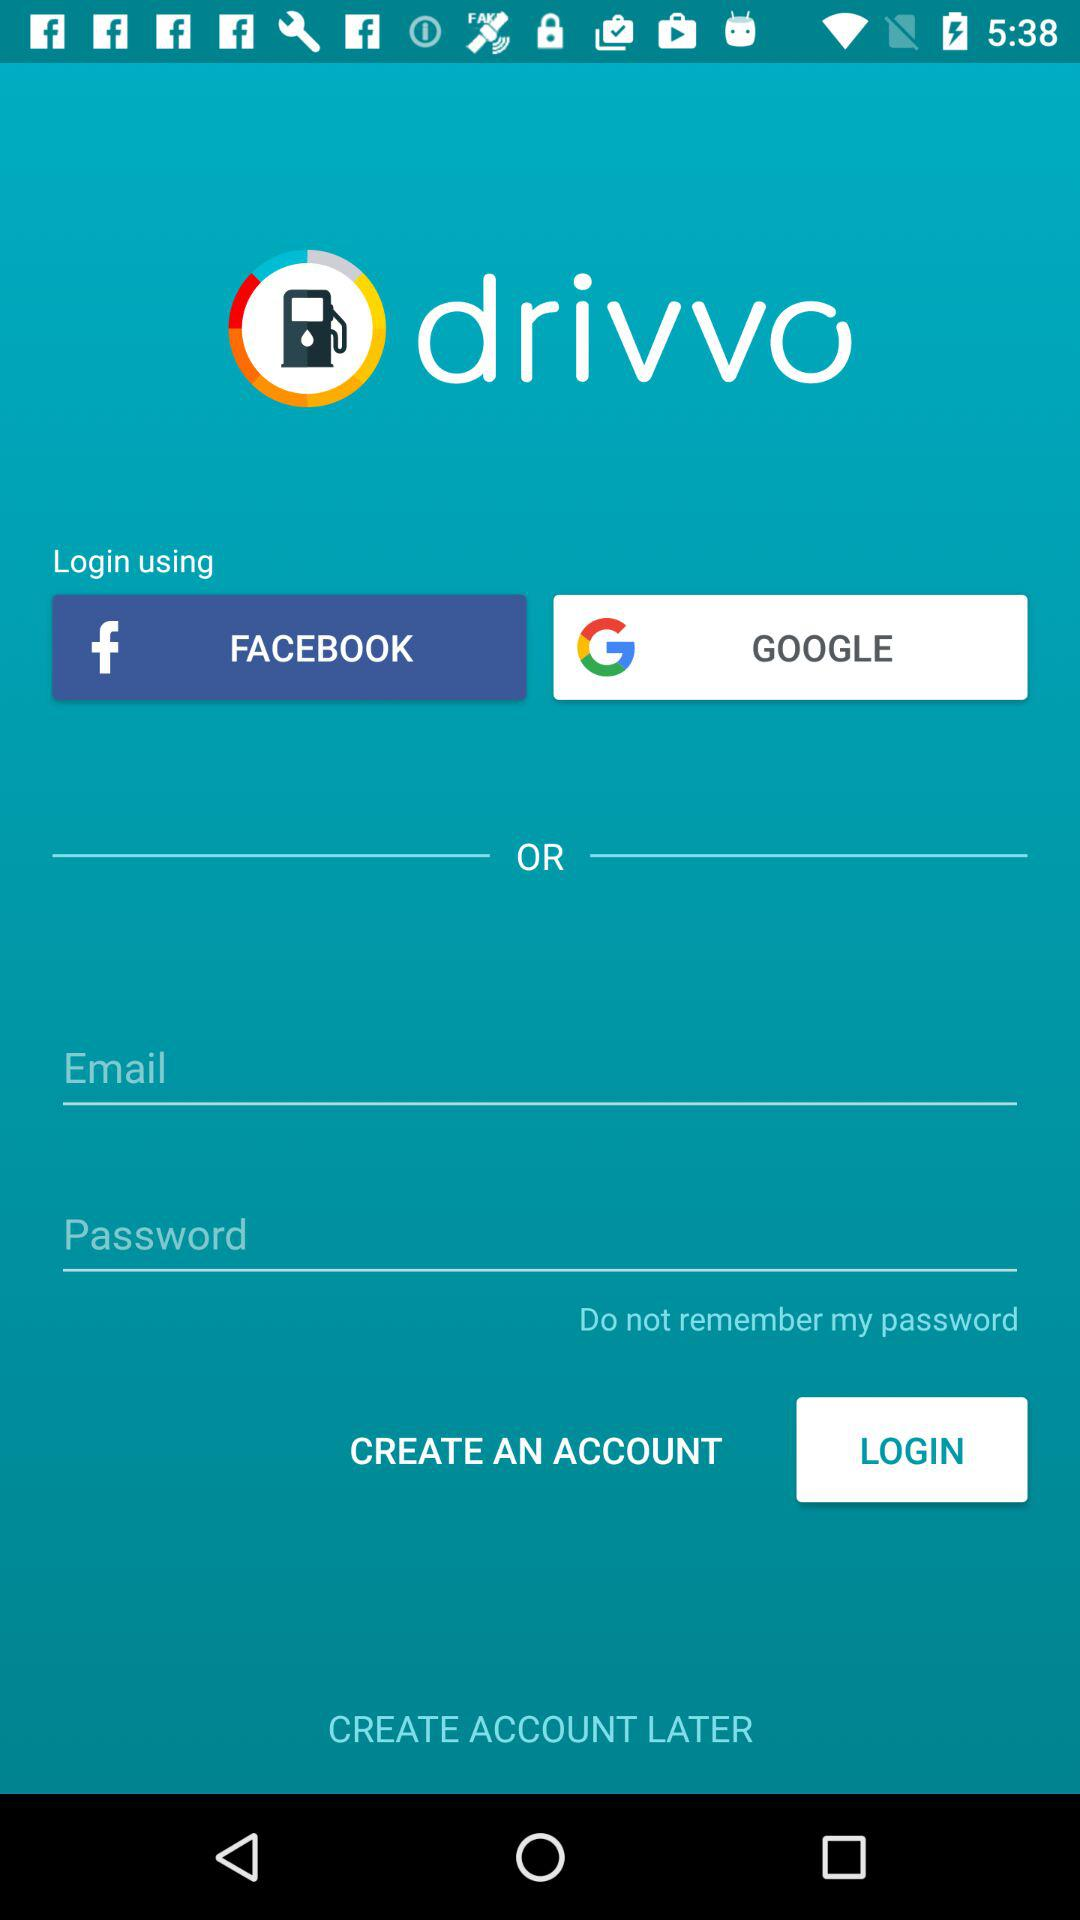How many fields are there to enter login credentials?
Answer the question using a single word or phrase. 2 